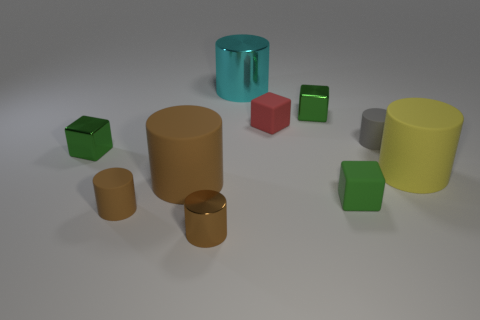Subtract all green blocks. How many were subtracted if there are1green blocks left? 2 Subtract all green blocks. How many blocks are left? 1 Subtract all red cubes. How many cubes are left? 3 Subtract all cylinders. How many objects are left? 4 Subtract all cyan cylinders. How many green cubes are left? 3 Subtract 3 blocks. How many blocks are left? 1 Subtract all blue cylinders. Subtract all cyan balls. How many cylinders are left? 6 Subtract all brown rubber objects. Subtract all metallic cylinders. How many objects are left? 6 Add 1 large metal cylinders. How many large metal cylinders are left? 2 Add 8 small blue shiny cubes. How many small blue shiny cubes exist? 8 